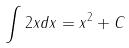<formula> <loc_0><loc_0><loc_500><loc_500>\int 2 x d x = x ^ { 2 } + C</formula> 